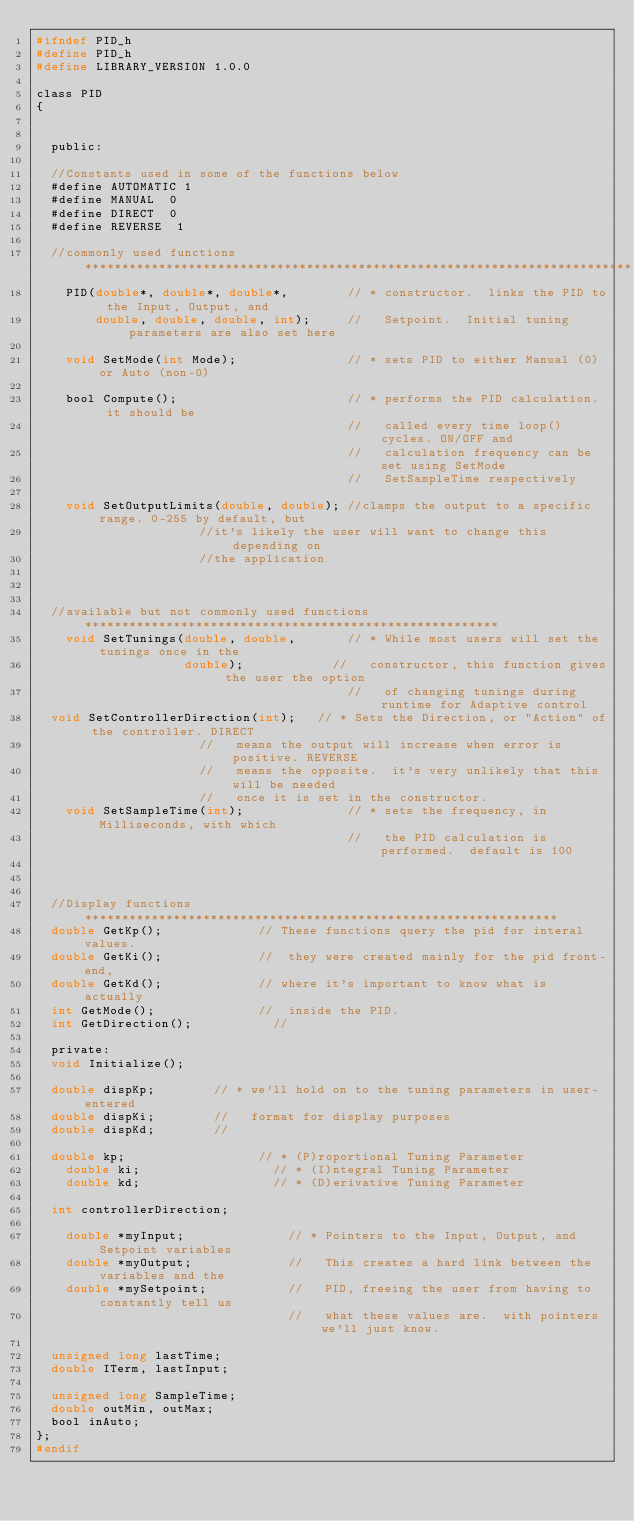Convert code to text. <code><loc_0><loc_0><loc_500><loc_500><_C_>#ifndef PID_h
#define PID_h
#define LIBRARY_VERSION	1.0.0

class PID
{


  public:

  //Constants used in some of the functions below
  #define AUTOMATIC	1
  #define MANUAL	0
  #define DIRECT  0
  #define REVERSE  1

  //commonly used functions **************************************************************************
    PID(double*, double*, double*,        // * constructor.  links the PID to the Input, Output, and
        double, double, double, int);     //   Setpoint.  Initial tuning parameters are also set here

    void SetMode(int Mode);               // * sets PID to either Manual (0) or Auto (non-0)

    bool Compute();                       // * performs the PID calculation.  it should be
                                          //   called every time loop() cycles. ON/OFF and
                                          //   calculation frequency can be set using SetMode
                                          //   SetSampleTime respectively

    void SetOutputLimits(double, double); //clamps the output to a specific range. 0-255 by default, but
										  //it's likely the user will want to change this depending on
										  //the application



  //available but not commonly used functions ********************************************************
    void SetTunings(double, double,       // * While most users will set the tunings once in the
                    double);         	  //   constructor, this function gives the user the option
                                          //   of changing tunings during runtime for Adaptive control
	void SetControllerDirection(int);	  // * Sets the Direction, or "Action" of the controller. DIRECT
										  //   means the output will increase when error is positive. REVERSE
										  //   means the opposite.  it's very unlikely that this will be needed
										  //   once it is set in the constructor.
    void SetSampleTime(int);              // * sets the frequency, in Milliseconds, with which
                                          //   the PID calculation is performed.  default is 100



  //Display functions ****************************************************************
	double GetKp();						  // These functions query the pid for interal values.
	double GetKi();						  //  they were created mainly for the pid front-end,
	double GetKd();						  // where it's important to know what is actually
	int GetMode();						  //  inside the PID.
	int GetDirection();					  //

  private:
	void Initialize();

	double dispKp;				// * we'll hold on to the tuning parameters in user-entered
	double dispKi;				//   format for display purposes
	double dispKd;				//

	double kp;                  // * (P)roportional Tuning Parameter
    double ki;                  // * (I)ntegral Tuning Parameter
    double kd;                  // * (D)erivative Tuning Parameter

	int controllerDirection;

    double *myInput;              // * Pointers to the Input, Output, and Setpoint variables
    double *myOutput;             //   This creates a hard link between the variables and the
    double *mySetpoint;           //   PID, freeing the user from having to constantly tell us
                                  //   what these values are.  with pointers we'll just know.

	unsigned long lastTime;
	double ITerm, lastInput;

	unsigned long SampleTime;
	double outMin, outMax;
	bool inAuto;
};
#endif

</code> 